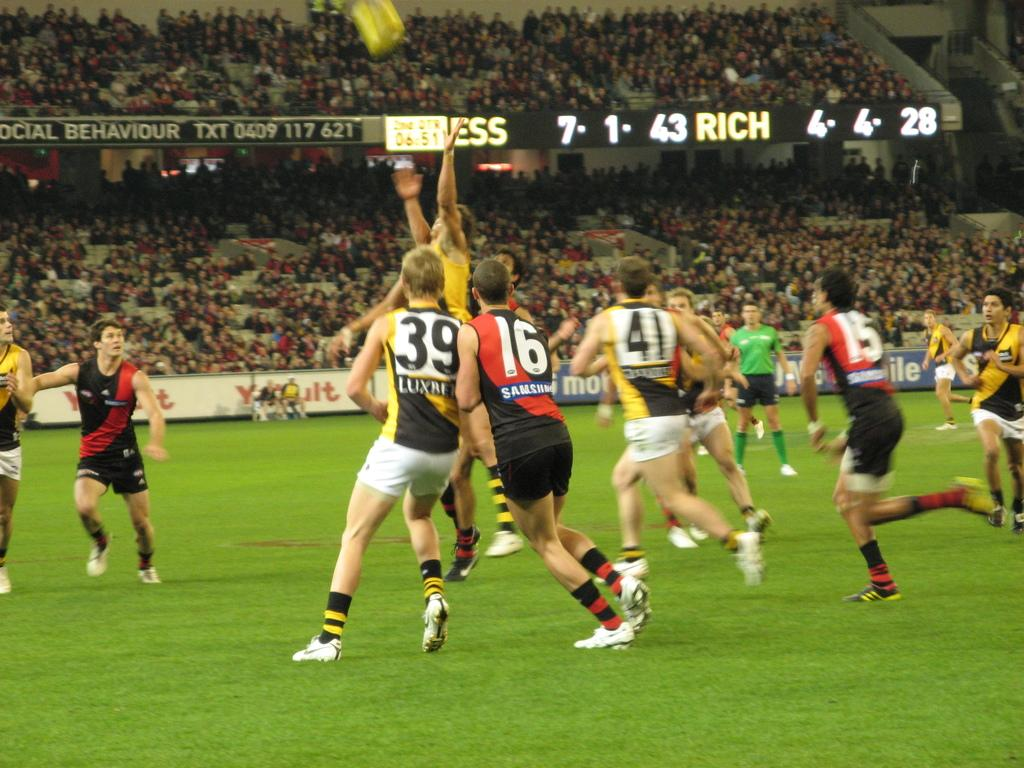<image>
Create a compact narrative representing the image presented. Athletes wearing the numbers 39 and 16 colliding into each other on the field. 